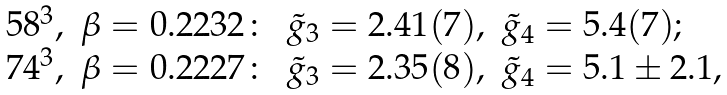<formula> <loc_0><loc_0><loc_500><loc_500>\begin{array} { l l l l } 5 8 ^ { 3 } , & \beta = 0 . 2 2 3 2 \colon & \tilde { g } _ { 3 } = 2 . 4 1 ( 7 ) , & \tilde { g } _ { 4 } = 5 . 4 ( 7 ) ; \\ 7 4 ^ { 3 } , & \beta = 0 . 2 2 2 7 \colon & \tilde { g } _ { 3 } = 2 . 3 5 ( 8 ) , & \tilde { g } _ { 4 } = 5 . 1 \pm 2 . 1 , \end{array}</formula> 